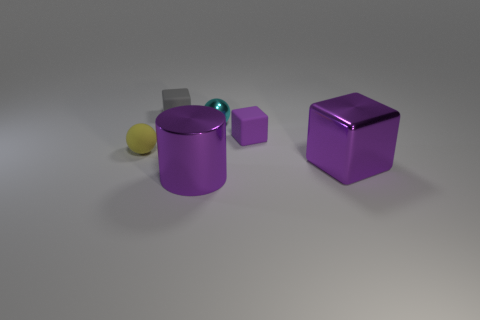Is the color of the large cylinder the same as the shiny cube?
Give a very brief answer. Yes. Are there any tiny rubber objects of the same color as the big metallic cylinder?
Your answer should be compact. Yes. What color is the matte sphere that is the same size as the gray cube?
Offer a terse response. Yellow. Are there any other tiny shiny objects that have the same shape as the gray object?
Your answer should be compact. No. What shape is the big object that is the same color as the cylinder?
Provide a succinct answer. Cube. There is a shiny block on the right side of the matte cube to the left of the shiny cylinder; are there any small matte cubes that are behind it?
Offer a very short reply. Yes. There is a cyan shiny thing that is the same size as the gray rubber thing; what shape is it?
Provide a short and direct response. Sphere. The other big object that is the same shape as the gray object is what color?
Keep it short and to the point. Purple. What number of things are either purple cylinders or large metallic blocks?
Your response must be concise. 2. Does the purple object to the left of the small metal thing have the same shape as the small rubber object that is on the right side of the gray rubber block?
Make the answer very short. No. 